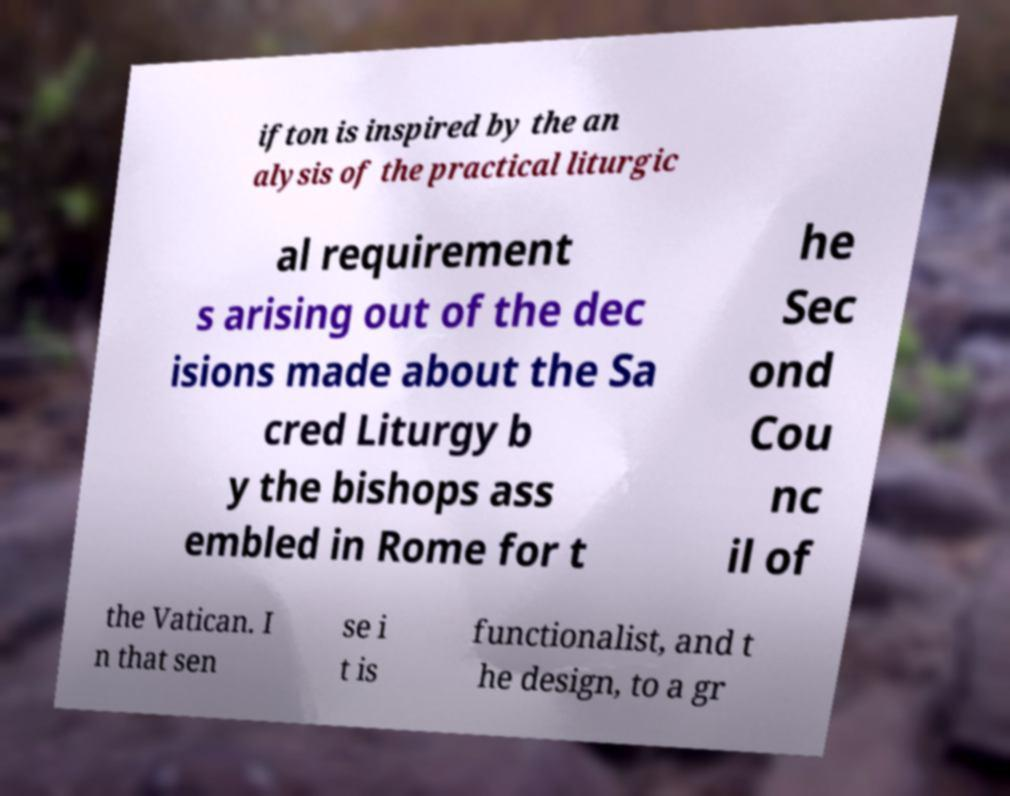Can you read and provide the text displayed in the image?This photo seems to have some interesting text. Can you extract and type it out for me? ifton is inspired by the an alysis of the practical liturgic al requirement s arising out of the dec isions made about the Sa cred Liturgy b y the bishops ass embled in Rome for t he Sec ond Cou nc il of the Vatican. I n that sen se i t is functionalist, and t he design, to a gr 